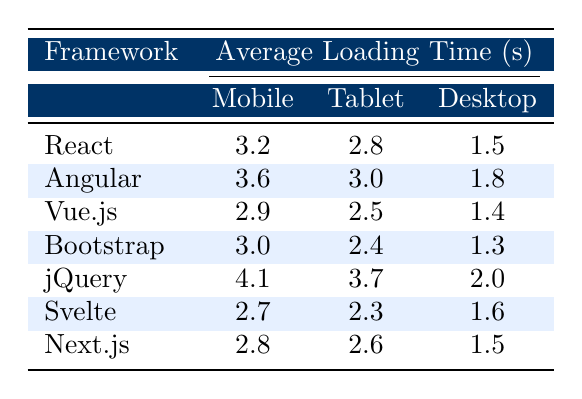What is the average loading time for the Bootstrap framework on a Mobile device? According to the table, the average loading time for Bootstrap on Mobile is 3.0 seconds.
Answer: 3.0 Which framework has the highest average loading time on Desktop? Reviewing the Desktop column, jQuery shows the highest average loading time of 2.0 seconds.
Answer: jQuery What is the loading time difference between Angular's Mobile and Tablet versions? Angular's Mobile loading time is 3.6 seconds and Tablet loading time is 3.0 seconds. The difference is 3.6 - 3.0 = 0.6 seconds.
Answer: 0.6 Which device type generally has the lowest average loading times across all frameworks listed? By examining the Desktop column, it shows the lowest average loading time compared to Mobile and Tablet for each framework.
Answer: Desktop Is React faster than jQuery on Mobile devices? React has an average loading time of 3.2 seconds, while jQuery has 4.1 seconds. Therefore, React is faster.
Answer: Yes What is the average loading time for Vue.js on Tablet and Desktop combined? The average loading time on Tablet is 2.5 seconds, and on Desktop, it is 1.4 seconds. To find the average of both: (2.5 + 1.4) / 2 = 1.95 seconds.
Answer: 1.95 Among all frameworks, which one has the lowest loading time on Desktop? Looking at the Desktop column, Bootstrap is the framework with the lowest loading time of 1.3 seconds.
Answer: Bootstrap What is the percentage increase in average loading time from Vue.js on Mobile to jQuery on Mobile? Vue.js Mobile average loading time is 2.9 seconds and jQuery Mobile is 4.1 seconds. The increase is (4.1 - 2.9) / 2.9 * 100% = 41.0%.
Answer: 41.0% Is there any framework that has an average loading time of 3.5 seconds or more on Tablet? By checking the Tablet loading times, only Angular at 3.0 seconds does not reach 3.5 seconds, therefore, no framework meets this criterion.
Answer: No What is the overall average loading time for Svelte across all devices? The average loading times are 2.7 seconds (Mobile), 2.3 seconds (Tablet), and 1.6 seconds (Desktop). The overall average is (2.7 + 2.3 + 1.6) / 3 = 2.2 seconds.
Answer: 2.2 